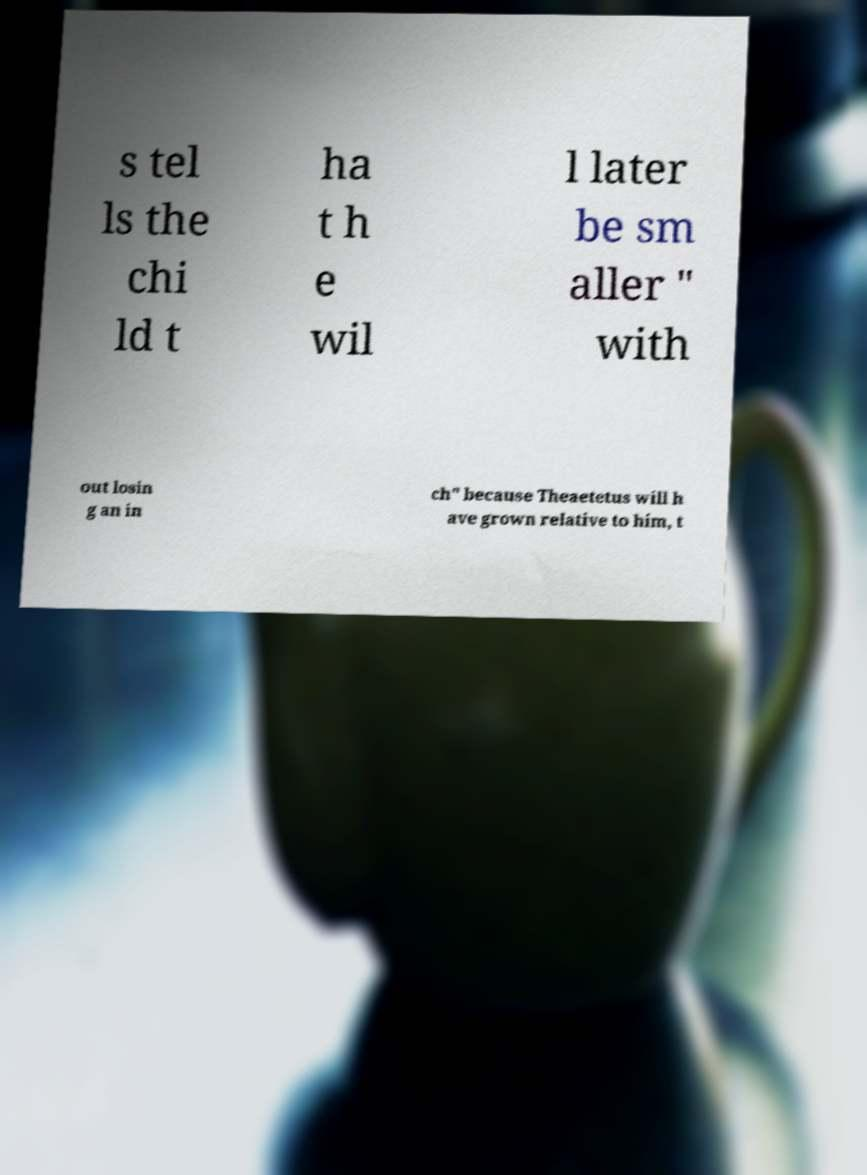Can you read and provide the text displayed in the image?This photo seems to have some interesting text. Can you extract and type it out for me? s tel ls the chi ld t ha t h e wil l later be sm aller " with out losin g an in ch" because Theaetetus will h ave grown relative to him, t 